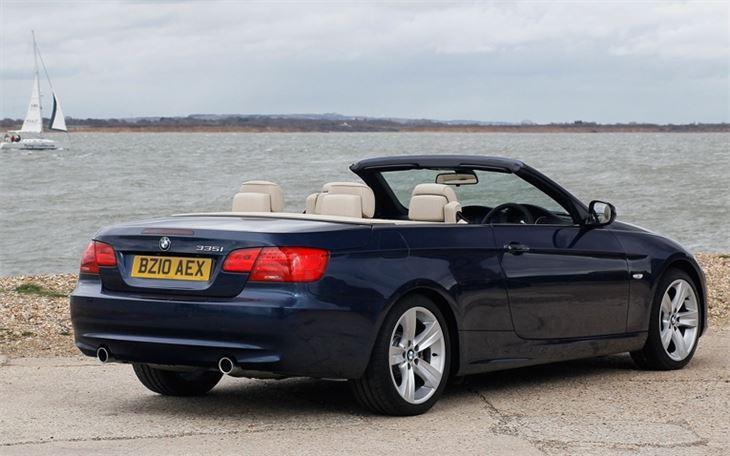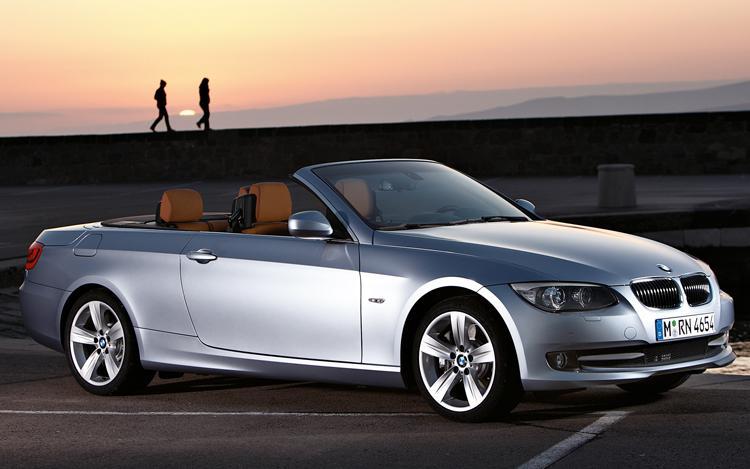The first image is the image on the left, the second image is the image on the right. For the images shown, is this caption "One convertible faces away from the camera, and the other is silver and facing rightward." true? Answer yes or no. Yes. The first image is the image on the left, the second image is the image on the right. Given the left and right images, does the statement "An image has a blue convertible sports car." hold true? Answer yes or no. Yes. 